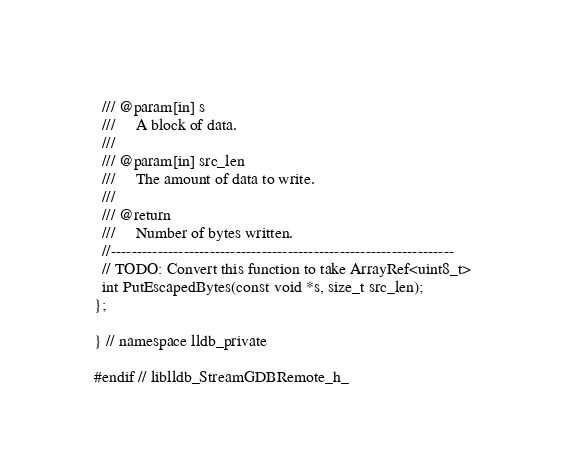Convert code to text. <code><loc_0><loc_0><loc_500><loc_500><_C_>  /// @param[in] s
  ///     A block of data.
  ///
  /// @param[in] src_len
  ///     The amount of data to write.
  ///
  /// @return
  ///     Number of bytes written.
  //------------------------------------------------------------------
  // TODO: Convert this function to take ArrayRef<uint8_t>
  int PutEscapedBytes(const void *s, size_t src_len);
};

} // namespace lldb_private

#endif // liblldb_StreamGDBRemote_h_
</code> 